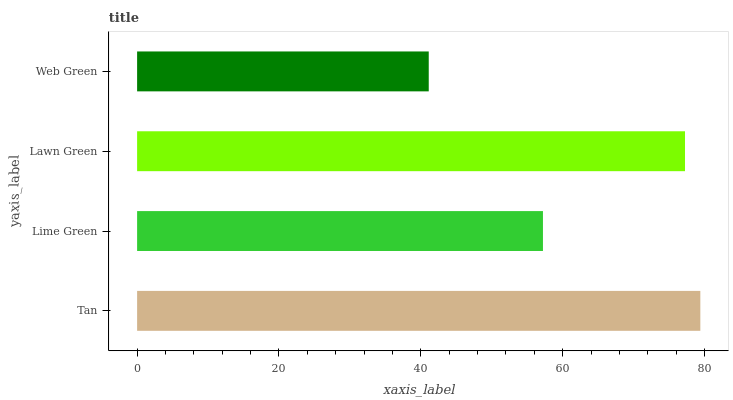Is Web Green the minimum?
Answer yes or no. Yes. Is Tan the maximum?
Answer yes or no. Yes. Is Lime Green the minimum?
Answer yes or no. No. Is Lime Green the maximum?
Answer yes or no. No. Is Tan greater than Lime Green?
Answer yes or no. Yes. Is Lime Green less than Tan?
Answer yes or no. Yes. Is Lime Green greater than Tan?
Answer yes or no. No. Is Tan less than Lime Green?
Answer yes or no. No. Is Lawn Green the high median?
Answer yes or no. Yes. Is Lime Green the low median?
Answer yes or no. Yes. Is Web Green the high median?
Answer yes or no. No. Is Tan the low median?
Answer yes or no. No. 